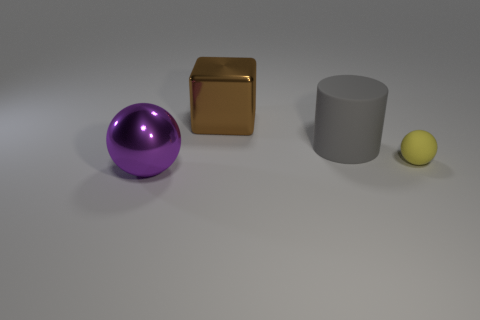The cylinder that is made of the same material as the small sphere is what color?
Offer a terse response. Gray. Is there any other thing that is the same size as the yellow thing?
Keep it short and to the point. No. How many large objects are yellow matte balls or brown blocks?
Ensure brevity in your answer.  1. Are there fewer large cyan rubber things than purple spheres?
Your answer should be compact. Yes. What is the color of the large thing that is the same shape as the tiny yellow rubber object?
Provide a succinct answer. Purple. Is there any other thing that has the same shape as the tiny yellow matte thing?
Ensure brevity in your answer.  Yes. Is the number of gray cylinders greater than the number of big cyan blocks?
Give a very brief answer. Yes. What number of other things are the same material as the small yellow object?
Offer a very short reply. 1. There is a big thing that is on the right side of the big cube behind the matte thing that is right of the big gray matte thing; what shape is it?
Ensure brevity in your answer.  Cylinder. Is the number of cylinders that are to the right of the tiny thing less than the number of balls behind the purple metal sphere?
Provide a succinct answer. Yes. 